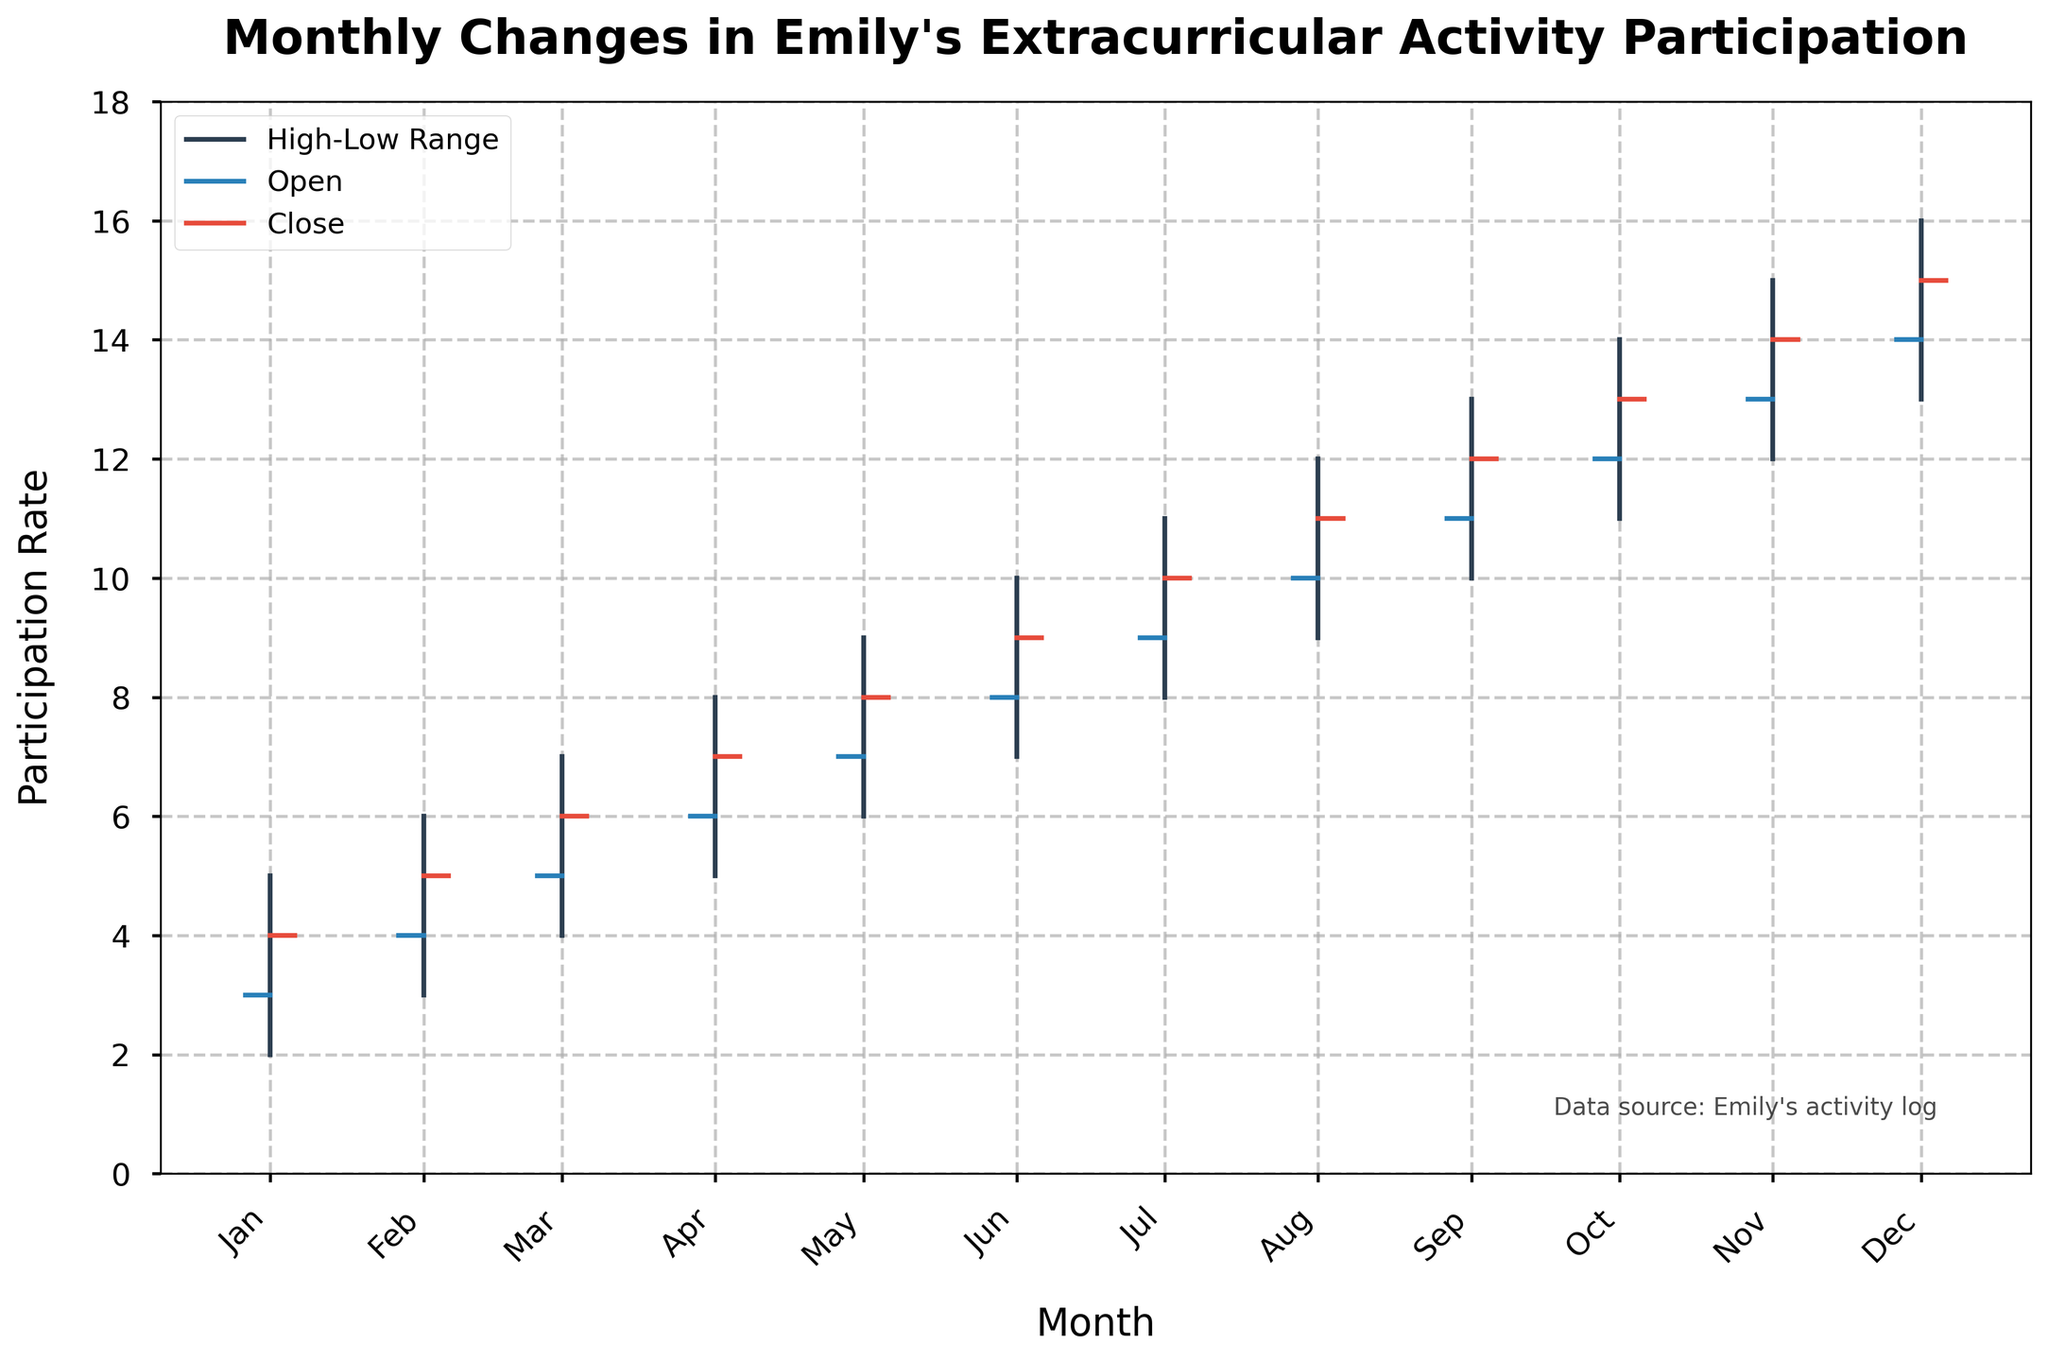How many months are displayed in the figure? Count the number of data points along the x-axis. Each point represents a month from January to December, totaling 12 months.
Answer: 12 What is the highest participation rate recorded? Identify the highest point among the high values for each month. The highest value is in the month of December, and it is 16.
Answer: 16 Which month has the lowest participation rate? Examine the low values for each month. The lowest recorded participation rate is in January, with a value of 2.
Answer: January In which month did Emily's participation close at the same rate it opened? Compare the open and close values for each month. For February (4 to 5), March (5 to 6), and so on till December (14 to 15), it can be clearly observed through the figure.
Answer: None What was the average participation rate at closing for the year? Sum the closing values for each month and then divide by the number of months: (4 + 5 + 6 + 7 + 8 + 9 + 10 + 11 + 12 + 13 + 14 + 15) / 12 = 9
Answer: 9 Which month saw the maximum increase in participation from open to close? Calculate the difference between the close and open values for each month. The month with the maximum increase is January, with an increase of 1 (4 - 3).
Answer: January How did Emily's participation trend throughout the year? Analyze the month-by-month changes in the open, high, low, and close values. The participation shows a consistent upward trend, with all values generally increasing month over month.
Answer: Upward trend What was the range of participation rates in July? The range is determined by subtracting the low value from the high value for July: 11 - 8 = 3.
Answer: 3 Which month had the smallest difference between its high and low values? Calculate and compare the high-low differences for each month. January has the smallest difference, 5 - 2 = 3.
Answer: January By how much did Emily's participation rate increase from the start of the year (January Open) to the end of the year (December Close)? Subtract the open value in January from the close value in December: 15 - 3 = 12.
Answer: 12 